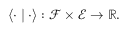<formula> <loc_0><loc_0><loc_500><loc_500>\langle \cdot | \cdot \rangle \colon \mathcal { F } \times \mathcal { E } \to \mathbb { R } .</formula> 